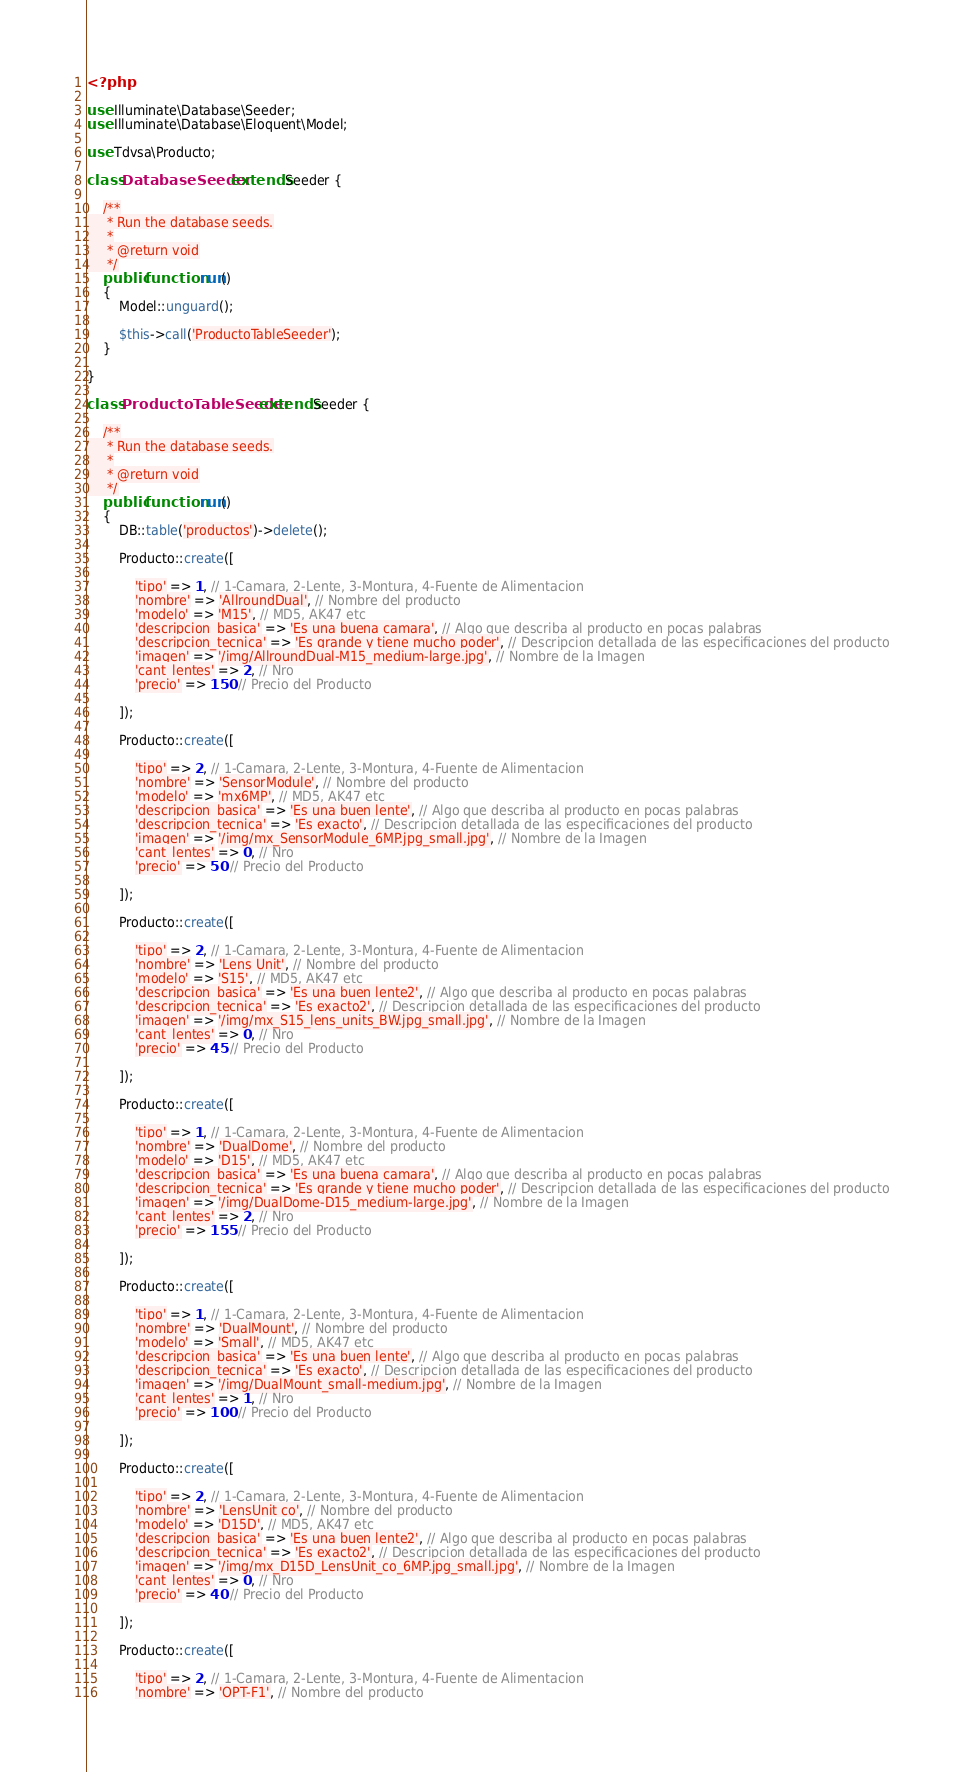<code> <loc_0><loc_0><loc_500><loc_500><_PHP_><?php

use Illuminate\Database\Seeder;
use Illuminate\Database\Eloquent\Model;

use Tdvsa\Producto;

class DatabaseSeeder extends Seeder {

	/**
	 * Run the database seeds.
	 *
	 * @return void
	 */
	public function run()
	{
		Model::unguard();

		$this->call('ProductoTableSeeder');
	}

}

class ProductoTableSeeder extends Seeder {

	/**
	 * Run the database seeds.
	 *
	 * @return void
	 */
	public function run()
	{
		DB::table('productos')->delete();

		Producto::create([

			'tipo' => 1, // 1-Camara, 2-Lente, 3-Montura, 4-Fuente de Alimentacion
			'nombre' => 'AllroundDual', // Nombre del producto
			'modelo' => 'M15', // MD5, AK47 etc
			'descripcion_basica' => 'Es una buena camara', // Algo que describa al producto en pocas palabras
			'descripcion_tecnica' => 'Es grande y tiene mucho poder', // Descripcion detallada de las especificaciones del producto
			'imagen' => '/img/AllroundDual-M15_medium-large.jpg', // Nombre de la Imagen
			'cant_lentes' => 2, // Nro
			'precio' => 150 // Precio del Producto

		]);

		Producto::create([

			'tipo' => 2, // 1-Camara, 2-Lente, 3-Montura, 4-Fuente de Alimentacion
			'nombre' => 'SensorModule', // Nombre del producto
			'modelo' => 'mx6MP', // MD5, AK47 etc
			'descripcion_basica' => 'Es una buen lente', // Algo que describa al producto en pocas palabras
			'descripcion_tecnica' => 'Es exacto', // Descripcion detallada de las especificaciones del producto
			'imagen' => '/img/mx_SensorModule_6MP.jpg_small.jpg', // Nombre de la Imagen
			'cant_lentes' => 0, // Nro
			'precio' => 50 // Precio del Producto

		]);

		Producto::create([

			'tipo' => 2, // 1-Camara, 2-Lente, 3-Montura, 4-Fuente de Alimentacion
			'nombre' => 'Lens Unit', // Nombre del producto
			'modelo' => 'S15', // MD5, AK47 etc
			'descripcion_basica' => 'Es una buen lente2', // Algo que describa al producto en pocas palabras
			'descripcion_tecnica' => 'Es exacto2', // Descripcion detallada de las especificaciones del producto
			'imagen' => '/img/mx_S15_lens_units_BW.jpg_small.jpg', // Nombre de la Imagen
			'cant_lentes' => 0, // Nro
			'precio' => 45 // Precio del Producto

		]);

		Producto::create([

			'tipo' => 1, // 1-Camara, 2-Lente, 3-Montura, 4-Fuente de Alimentacion
			'nombre' => 'DualDome', // Nombre del producto
			'modelo' => 'D15', // MD5, AK47 etc
			'descripcion_basica' => 'Es una buena camara', // Algo que describa al producto en pocas palabras
			'descripcion_tecnica' => 'Es grande y tiene mucho poder', // Descripcion detallada de las especificaciones del producto
			'imagen' => '/img/DualDome-D15_medium-large.jpg', // Nombre de la Imagen
			'cant_lentes' => 2, // Nro
			'precio' => 155 // Precio del Producto

		]);

		Producto::create([

			'tipo' => 1, // 1-Camara, 2-Lente, 3-Montura, 4-Fuente de Alimentacion
			'nombre' => 'DualMount', // Nombre del producto
			'modelo' => 'Small', // MD5, AK47 etc
			'descripcion_basica' => 'Es una buen lente', // Algo que describa al producto en pocas palabras
			'descripcion_tecnica' => 'Es exacto', // Descripcion detallada de las especificaciones del producto
			'imagen' => '/img/DualMount_small-medium.jpg', // Nombre de la Imagen
			'cant_lentes' => 1, // Nro
			'precio' => 100 // Precio del Producto

		]);

		Producto::create([

			'tipo' => 2, // 1-Camara, 2-Lente, 3-Montura, 4-Fuente de Alimentacion
			'nombre' => 'LensUnit co', // Nombre del producto
			'modelo' => 'D15D', // MD5, AK47 etc
			'descripcion_basica' => 'Es una buen lente2', // Algo que describa al producto en pocas palabras
			'descripcion_tecnica' => 'Es exacto2', // Descripcion detallada de las especificaciones del producto
			'imagen' => '/img/mx_D15D_LensUnit_co_6MP.jpg_small.jpg', // Nombre de la Imagen
			'cant_lentes' => 0, // Nro
			'precio' => 40 // Precio del Producto

		]);

		Producto::create([

			'tipo' => 2, // 1-Camara, 2-Lente, 3-Montura, 4-Fuente de Alimentacion
			'nombre' => 'OPT-F1', // Nombre del producto</code> 